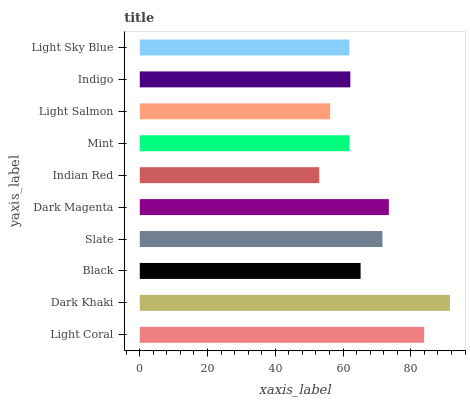Is Indian Red the minimum?
Answer yes or no. Yes. Is Dark Khaki the maximum?
Answer yes or no. Yes. Is Black the minimum?
Answer yes or no. No. Is Black the maximum?
Answer yes or no. No. Is Dark Khaki greater than Black?
Answer yes or no. Yes. Is Black less than Dark Khaki?
Answer yes or no. Yes. Is Black greater than Dark Khaki?
Answer yes or no. No. Is Dark Khaki less than Black?
Answer yes or no. No. Is Black the high median?
Answer yes or no. Yes. Is Indigo the low median?
Answer yes or no. Yes. Is Indian Red the high median?
Answer yes or no. No. Is Light Salmon the low median?
Answer yes or no. No. 